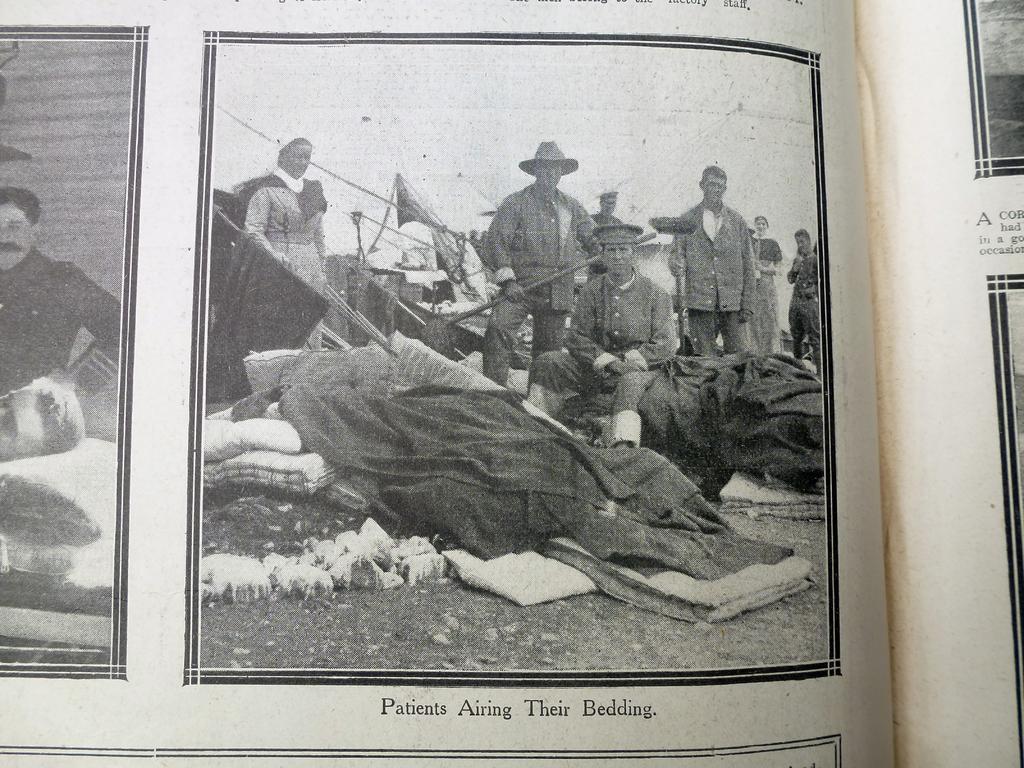Describe this image in one or two sentences. This is a picture of a page of a book as we can see there are some persons standing, and one person is sitting in the middle of this image, and there is some text at the bottom of this image. 